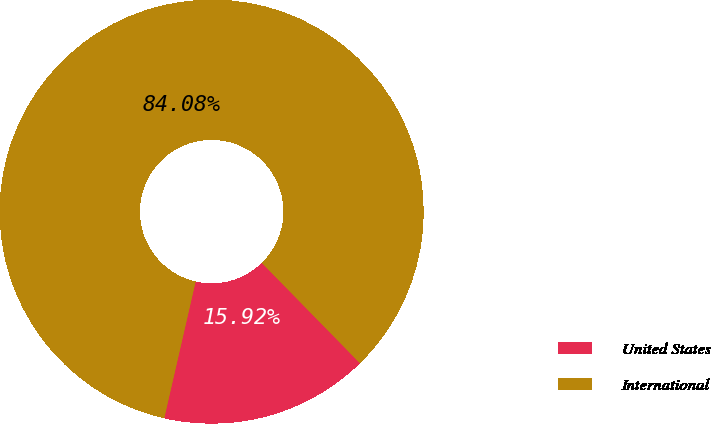Convert chart to OTSL. <chart><loc_0><loc_0><loc_500><loc_500><pie_chart><fcel>United States<fcel>International<nl><fcel>15.92%<fcel>84.08%<nl></chart> 